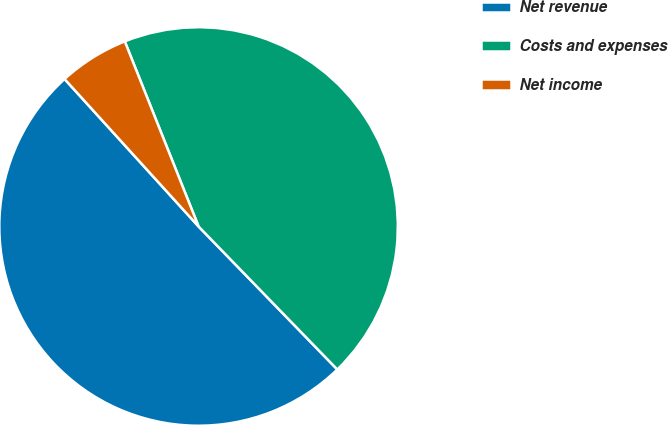<chart> <loc_0><loc_0><loc_500><loc_500><pie_chart><fcel>Net revenue<fcel>Costs and expenses<fcel>Net income<nl><fcel>50.52%<fcel>43.78%<fcel>5.7%<nl></chart> 